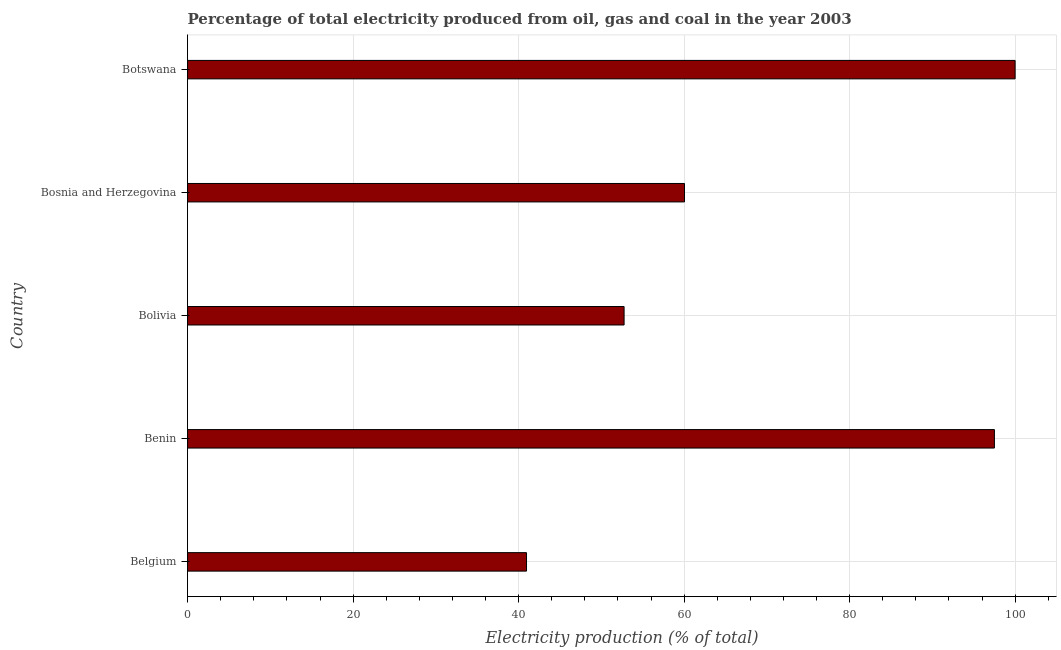Does the graph contain any zero values?
Offer a very short reply. No. Does the graph contain grids?
Offer a very short reply. Yes. What is the title of the graph?
Give a very brief answer. Percentage of total electricity produced from oil, gas and coal in the year 2003. What is the label or title of the X-axis?
Make the answer very short. Electricity production (% of total). What is the label or title of the Y-axis?
Your answer should be compact. Country. What is the electricity production in Bosnia and Herzegovina?
Provide a short and direct response. 60.05. Across all countries, what is the maximum electricity production?
Offer a very short reply. 100. Across all countries, what is the minimum electricity production?
Give a very brief answer. 40.96. In which country was the electricity production maximum?
Give a very brief answer. Botswana. In which country was the electricity production minimum?
Ensure brevity in your answer.  Belgium. What is the sum of the electricity production?
Your answer should be compact. 351.25. What is the difference between the electricity production in Bolivia and Bosnia and Herzegovina?
Your response must be concise. -7.3. What is the average electricity production per country?
Your answer should be compact. 70.25. What is the median electricity production?
Give a very brief answer. 60.05. In how many countries, is the electricity production greater than 52 %?
Offer a terse response. 4. Is the difference between the electricity production in Belgium and Benin greater than the difference between any two countries?
Your answer should be very brief. No. What is the difference between the highest and the second highest electricity production?
Your answer should be very brief. 2.5. What is the difference between the highest and the lowest electricity production?
Give a very brief answer. 59.04. In how many countries, is the electricity production greater than the average electricity production taken over all countries?
Your answer should be compact. 2. Are all the bars in the graph horizontal?
Provide a short and direct response. Yes. How many countries are there in the graph?
Provide a short and direct response. 5. What is the difference between two consecutive major ticks on the X-axis?
Give a very brief answer. 20. What is the Electricity production (% of total) in Belgium?
Offer a terse response. 40.96. What is the Electricity production (% of total) in Benin?
Keep it short and to the point. 97.5. What is the Electricity production (% of total) in Bolivia?
Give a very brief answer. 52.75. What is the Electricity production (% of total) of Bosnia and Herzegovina?
Your answer should be very brief. 60.05. What is the difference between the Electricity production (% of total) in Belgium and Benin?
Offer a terse response. -56.54. What is the difference between the Electricity production (% of total) in Belgium and Bolivia?
Your answer should be very brief. -11.79. What is the difference between the Electricity production (% of total) in Belgium and Bosnia and Herzegovina?
Your response must be concise. -19.09. What is the difference between the Electricity production (% of total) in Belgium and Botswana?
Your answer should be very brief. -59.04. What is the difference between the Electricity production (% of total) in Benin and Bolivia?
Provide a short and direct response. 44.75. What is the difference between the Electricity production (% of total) in Benin and Bosnia and Herzegovina?
Give a very brief answer. 37.45. What is the difference between the Electricity production (% of total) in Bolivia and Bosnia and Herzegovina?
Provide a short and direct response. -7.3. What is the difference between the Electricity production (% of total) in Bolivia and Botswana?
Give a very brief answer. -47.25. What is the difference between the Electricity production (% of total) in Bosnia and Herzegovina and Botswana?
Offer a terse response. -39.95. What is the ratio of the Electricity production (% of total) in Belgium to that in Benin?
Provide a succinct answer. 0.42. What is the ratio of the Electricity production (% of total) in Belgium to that in Bolivia?
Provide a short and direct response. 0.78. What is the ratio of the Electricity production (% of total) in Belgium to that in Bosnia and Herzegovina?
Your answer should be very brief. 0.68. What is the ratio of the Electricity production (% of total) in Belgium to that in Botswana?
Offer a terse response. 0.41. What is the ratio of the Electricity production (% of total) in Benin to that in Bolivia?
Your answer should be compact. 1.85. What is the ratio of the Electricity production (% of total) in Benin to that in Bosnia and Herzegovina?
Keep it short and to the point. 1.62. What is the ratio of the Electricity production (% of total) in Bolivia to that in Bosnia and Herzegovina?
Provide a succinct answer. 0.88. What is the ratio of the Electricity production (% of total) in Bolivia to that in Botswana?
Your answer should be very brief. 0.53. What is the ratio of the Electricity production (% of total) in Bosnia and Herzegovina to that in Botswana?
Make the answer very short. 0.6. 